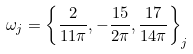Convert formula to latex. <formula><loc_0><loc_0><loc_500><loc_500>\omega _ { j } = \left \{ \frac { 2 } { 1 1 \pi } , - \frac { 1 5 } { 2 \pi } , \frac { 1 7 } { 1 4 \pi } \right \} _ { j }</formula> 